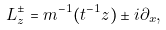Convert formula to latex. <formula><loc_0><loc_0><loc_500><loc_500>L _ { z } ^ { \pm } = m ^ { - 1 } ( t ^ { - 1 } z ) \pm i \partial _ { x } ,</formula> 